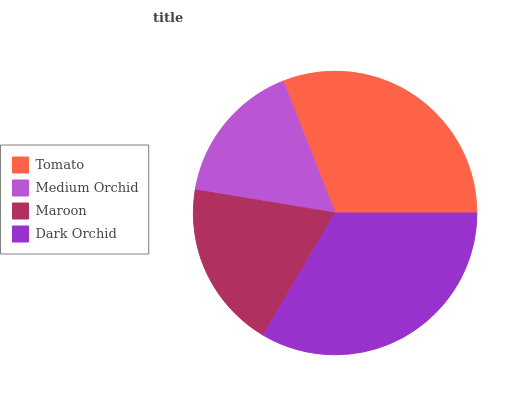Is Medium Orchid the minimum?
Answer yes or no. Yes. Is Dark Orchid the maximum?
Answer yes or no. Yes. Is Maroon the minimum?
Answer yes or no. No. Is Maroon the maximum?
Answer yes or no. No. Is Maroon greater than Medium Orchid?
Answer yes or no. Yes. Is Medium Orchid less than Maroon?
Answer yes or no. Yes. Is Medium Orchid greater than Maroon?
Answer yes or no. No. Is Maroon less than Medium Orchid?
Answer yes or no. No. Is Tomato the high median?
Answer yes or no. Yes. Is Maroon the low median?
Answer yes or no. Yes. Is Medium Orchid the high median?
Answer yes or no. No. Is Medium Orchid the low median?
Answer yes or no. No. 